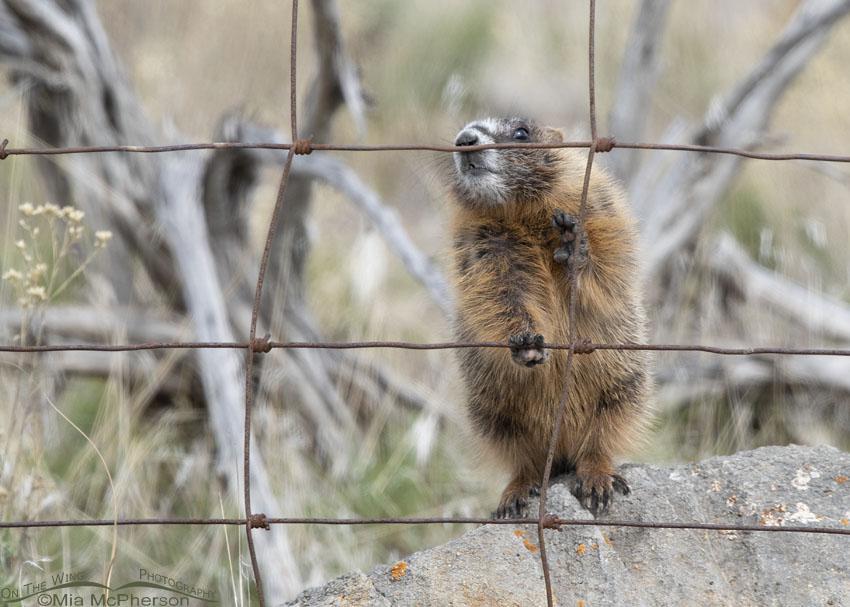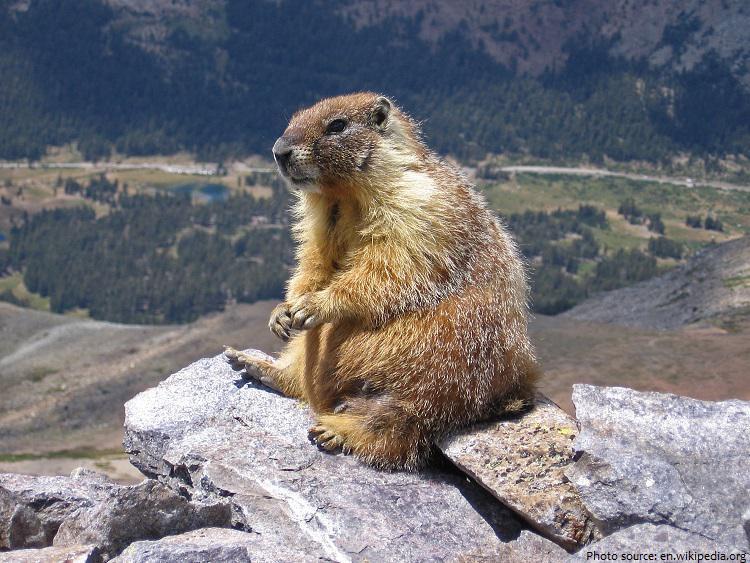The first image is the image on the left, the second image is the image on the right. Assess this claim about the two images: "In the left image, a brown furry animal is seen perched on a rock outside.". Correct or not? Answer yes or no. Yes. The first image is the image on the left, the second image is the image on the right. Examine the images to the left and right. Is the description "There are only 2 marmots." accurate? Answer yes or no. Yes. 